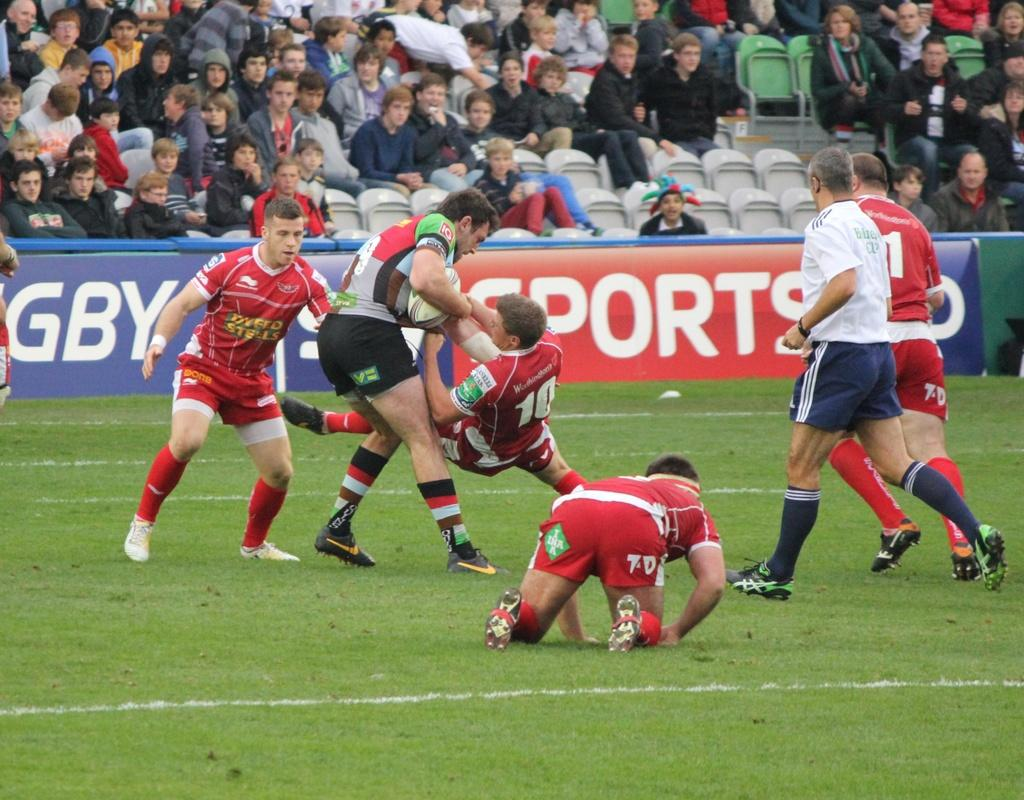<image>
Offer a succinct explanation of the picture presented. Soccer players on the field and a sign in the back that says "Sports". 